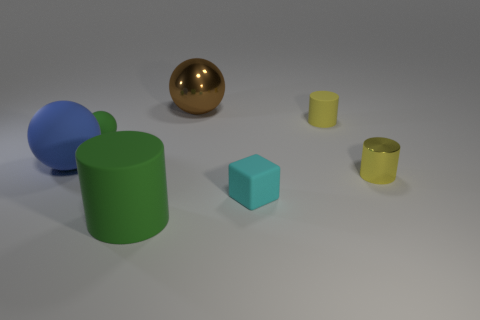Add 1 small cubes. How many objects exist? 8 Subtract all spheres. How many objects are left? 4 Subtract all big brown balls. Subtract all blue rubber things. How many objects are left? 5 Add 6 cylinders. How many cylinders are left? 9 Add 5 big rubber spheres. How many big rubber spheres exist? 6 Subtract 0 gray cylinders. How many objects are left? 7 